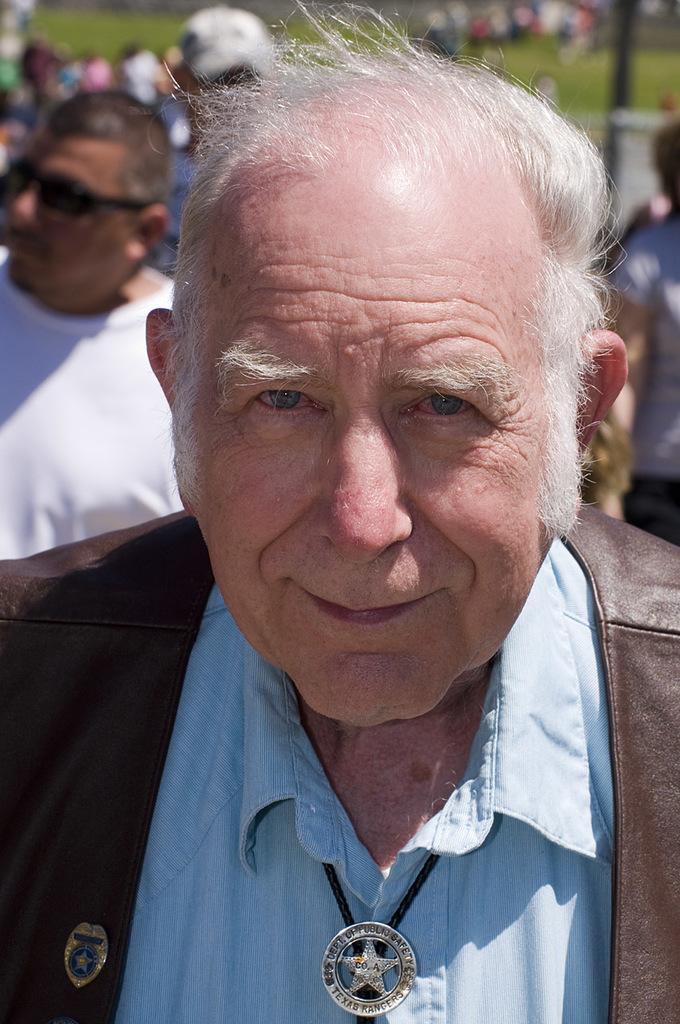Could you give a brief overview of what you see in this image? In this image I can see a person. In the background, I can see a group of people and the grass. 